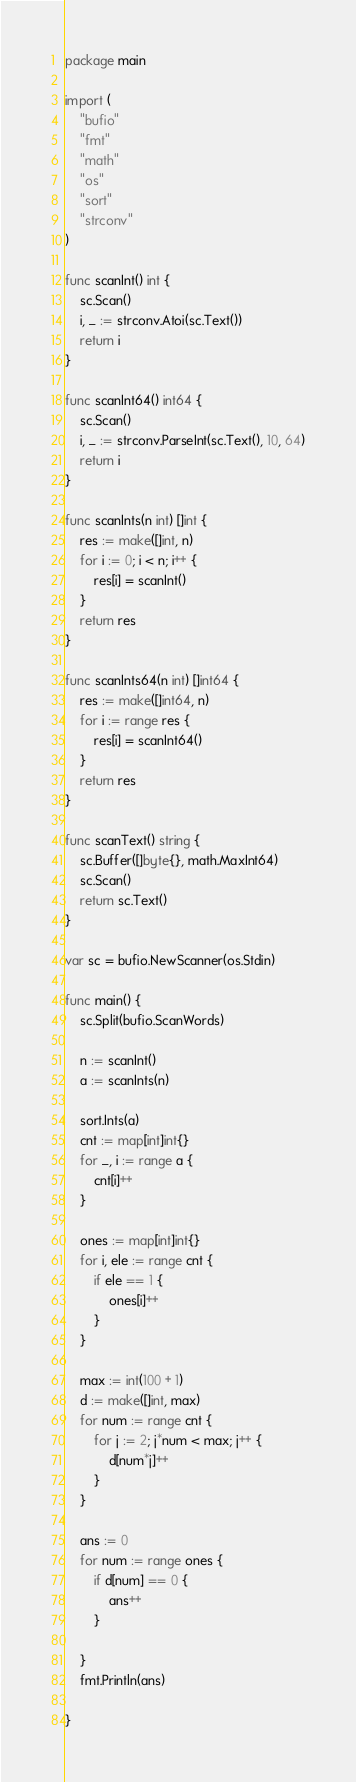<code> <loc_0><loc_0><loc_500><loc_500><_Go_>package main

import (
	"bufio"
	"fmt"
	"math"
	"os"
	"sort"
	"strconv"
)

func scanInt() int {
	sc.Scan()
	i, _ := strconv.Atoi(sc.Text())
	return i
}

func scanInt64() int64 {
	sc.Scan()
	i, _ := strconv.ParseInt(sc.Text(), 10, 64)
	return i
}

func scanInts(n int) []int {
	res := make([]int, n)
	for i := 0; i < n; i++ {
		res[i] = scanInt()
	}
	return res
}

func scanInts64(n int) []int64 {
	res := make([]int64, n)
	for i := range res {
		res[i] = scanInt64()
	}
	return res
}

func scanText() string {
	sc.Buffer([]byte{}, math.MaxInt64)
	sc.Scan()
	return sc.Text()
}

var sc = bufio.NewScanner(os.Stdin)

func main() {
	sc.Split(bufio.ScanWords)

	n := scanInt()
	a := scanInts(n)

	sort.Ints(a)
	cnt := map[int]int{}
	for _, i := range a {
		cnt[i]++
	}

	ones := map[int]int{}
	for i, ele := range cnt {
		if ele == 1 {
			ones[i]++
		}
	}

	max := int(100 + 1)
	d := make([]int, max)
	for num := range cnt {
		for j := 2; j*num < max; j++ {
			d[num*j]++
		}
	}

	ans := 0
	for num := range ones {
		if d[num] == 0 {
			ans++
		}

	}
	fmt.Println(ans)

}
</code> 